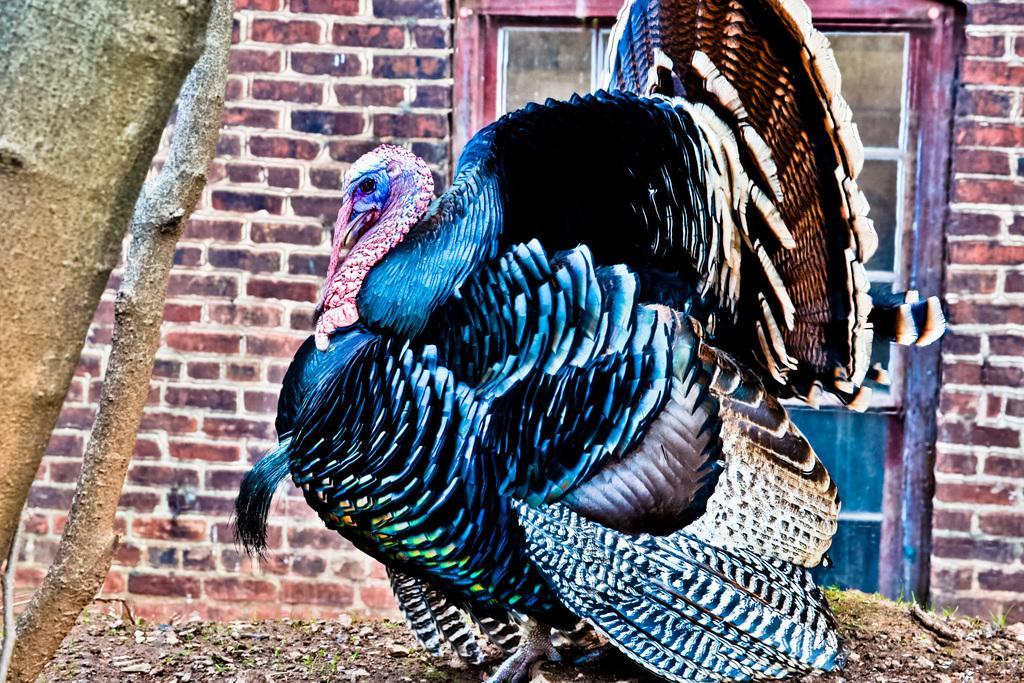How would you summarize this image in a sentence or two? In this picture, we see a turkey hen. It is in black color. It has a long pink beak. In the background, we see a building which is made up of bricks. We even see a door. On the left side, we see the stem of the tree. 